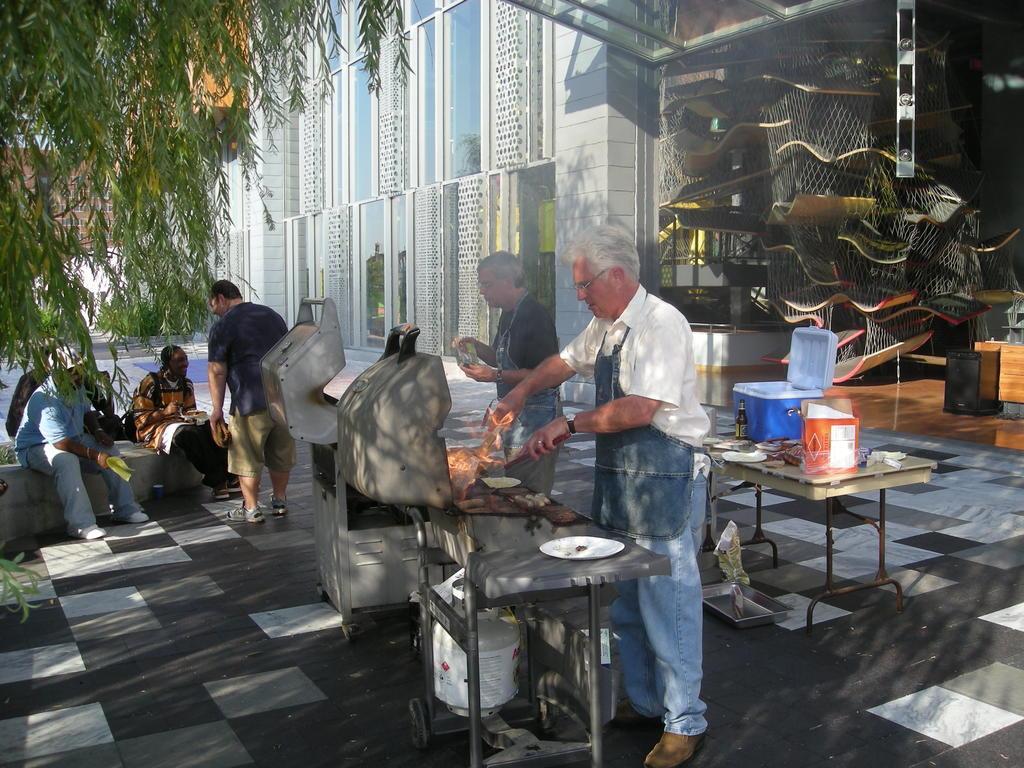How would you summarize this image in a sentence or two? In this image there are group of people sitting in a bench , another 2 persons standing and cooking in the Barbeque , and in the back ground there is bottle, container, box, plates on a table, building, net, trees, and another man standing by holding a container. 